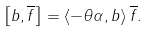<formula> <loc_0><loc_0><loc_500><loc_500>\left [ b , \overline { f } \right ] = \left \langle - \theta \alpha , b \right \rangle \overline { f } .</formula> 